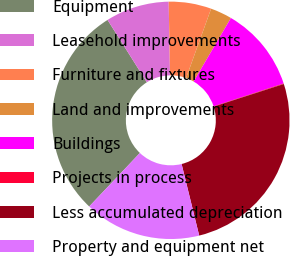Convert chart to OTSL. <chart><loc_0><loc_0><loc_500><loc_500><pie_chart><fcel>Equipment<fcel>Leasehold improvements<fcel>Furniture and fixtures<fcel>Land and improvements<fcel>Buildings<fcel>Projects in process<fcel>Less accumulated depreciation<fcel>Property and equipment net<nl><fcel>28.98%<fcel>8.66%<fcel>5.8%<fcel>2.94%<fcel>11.52%<fcel>0.08%<fcel>26.11%<fcel>15.91%<nl></chart> 